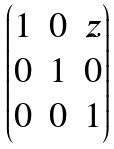Convert formula to latex. <formula><loc_0><loc_0><loc_500><loc_500>\begin{pmatrix} 1 & 0 & z \\ 0 & 1 & 0 \\ 0 & 0 & 1 \end{pmatrix}</formula> 